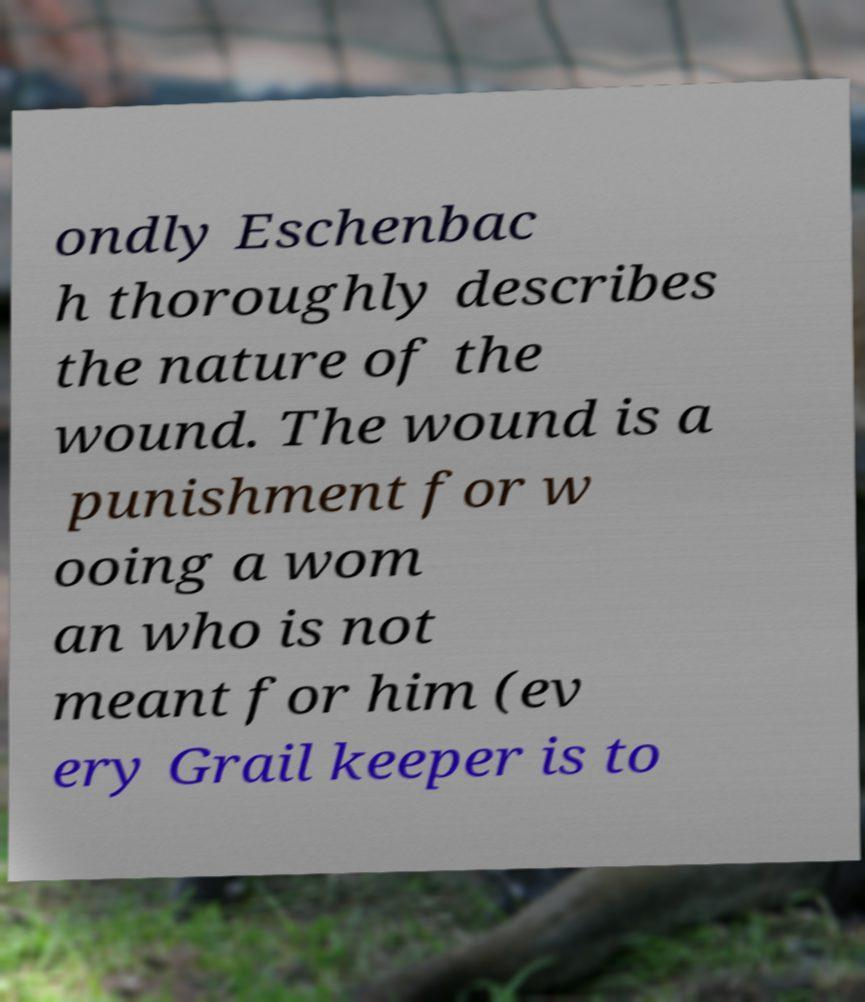Can you read and provide the text displayed in the image?This photo seems to have some interesting text. Can you extract and type it out for me? ondly Eschenbac h thoroughly describes the nature of the wound. The wound is a punishment for w ooing a wom an who is not meant for him (ev ery Grail keeper is to 